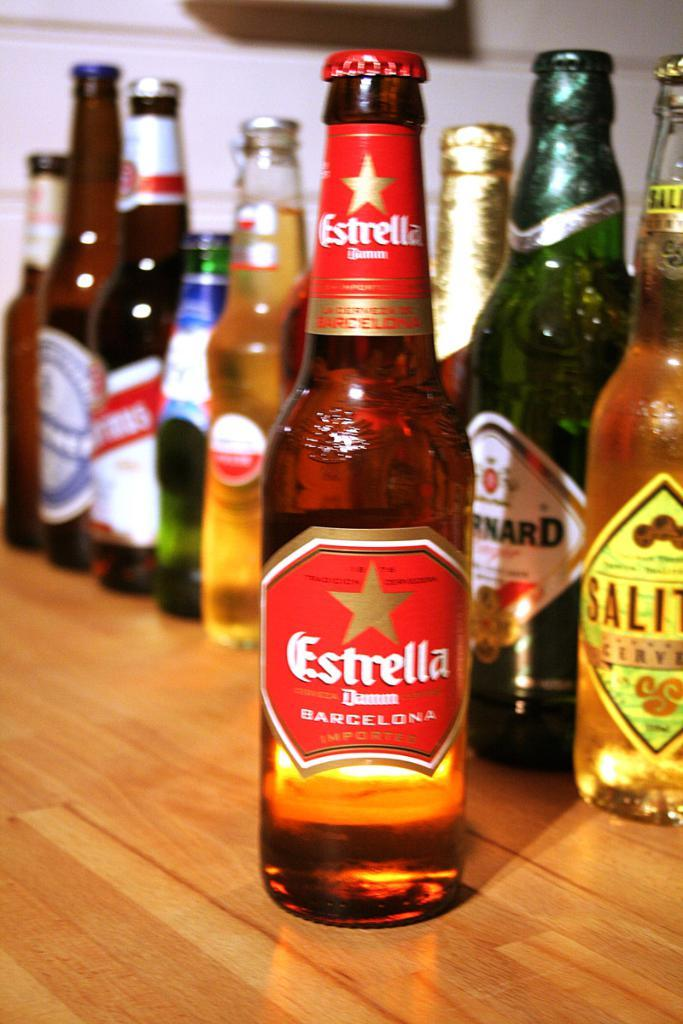<image>
Offer a succinct explanation of the picture presented. In front of many bottles of imported beer is a bottle with the label Estrella. 